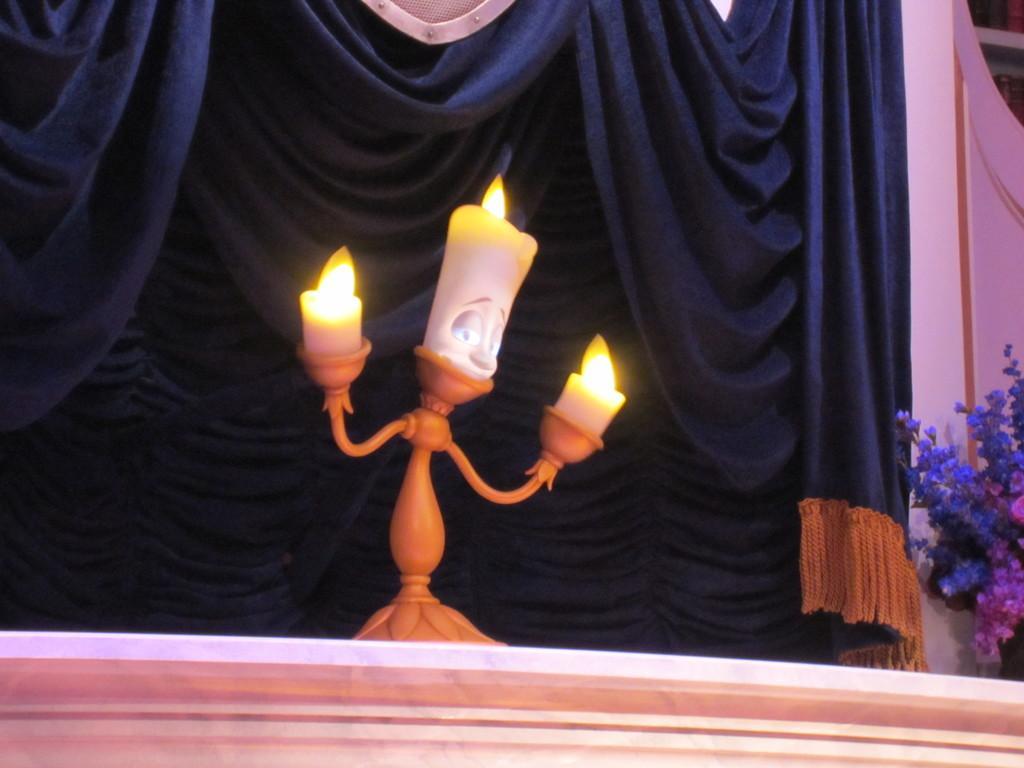Please provide a concise description of this image. In the image there are three candles kept on a single stand and in the background there is a curtain and beside the curtain there is a flower plant. 